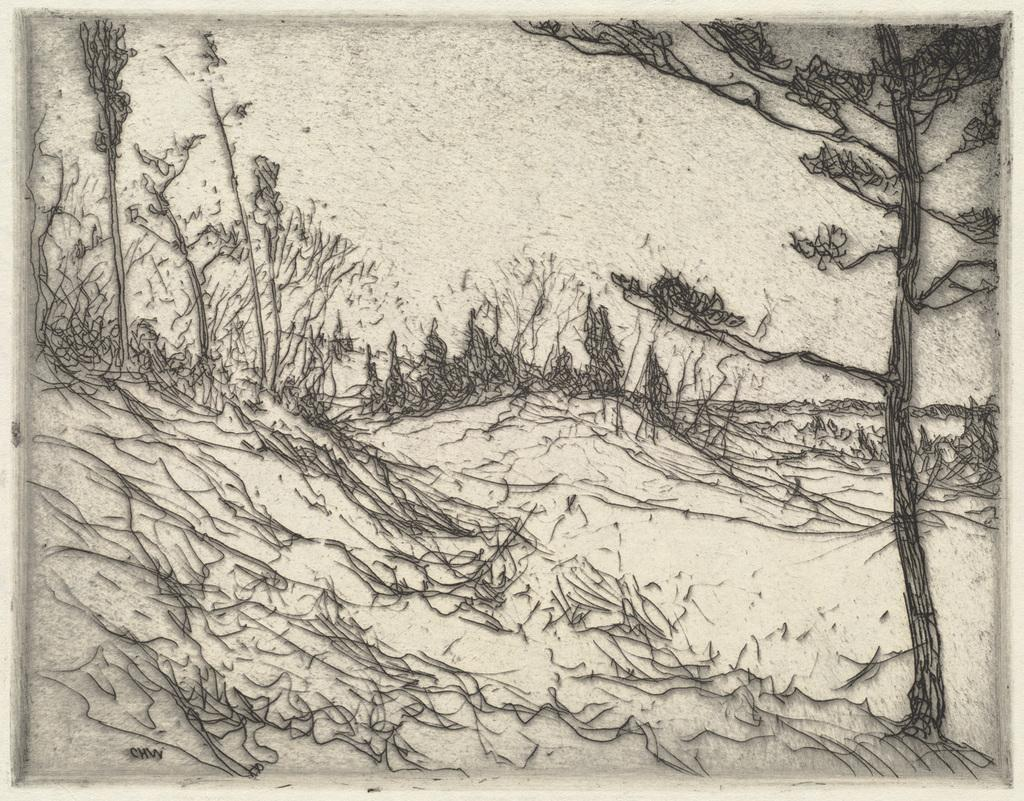What type of image is being described? The image is a drawing. What can be seen in the drawing? There are trees in the drawing. What type of pie is being served in the office in the drawing? There is no office or pie present in the drawing; it only features trees. How often does the artist wash their hands while creating the drawing? The artist's hand-washing habits are not mentioned or visible in the drawing, so it cannot be determined from the image. 